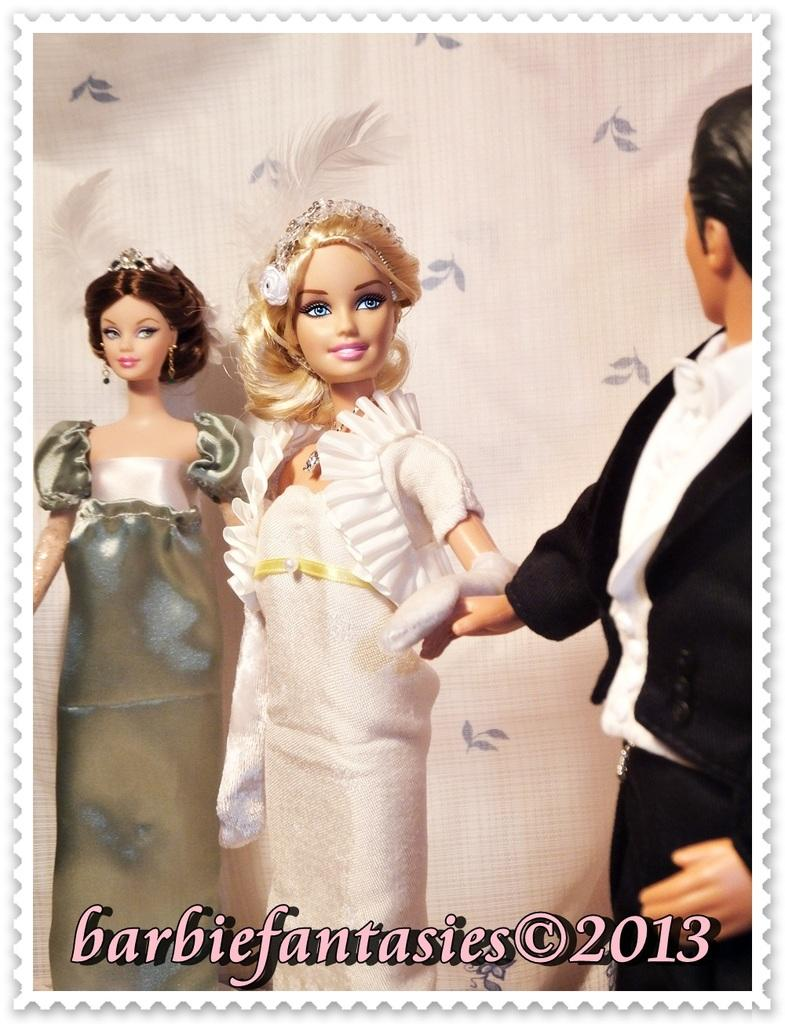How many dolls are present in the image? There are three dolls in the image: two Barbie dolls and one man doll. What type of dolls are featured in the image? The image features Barbie dolls and a man doll. What can be seen behind the dolls in the image? There is a background screen in the image. What type of hope can be seen growing on the branch in the image? There is no branch or hope present in the image; it features dolls and a background screen. 